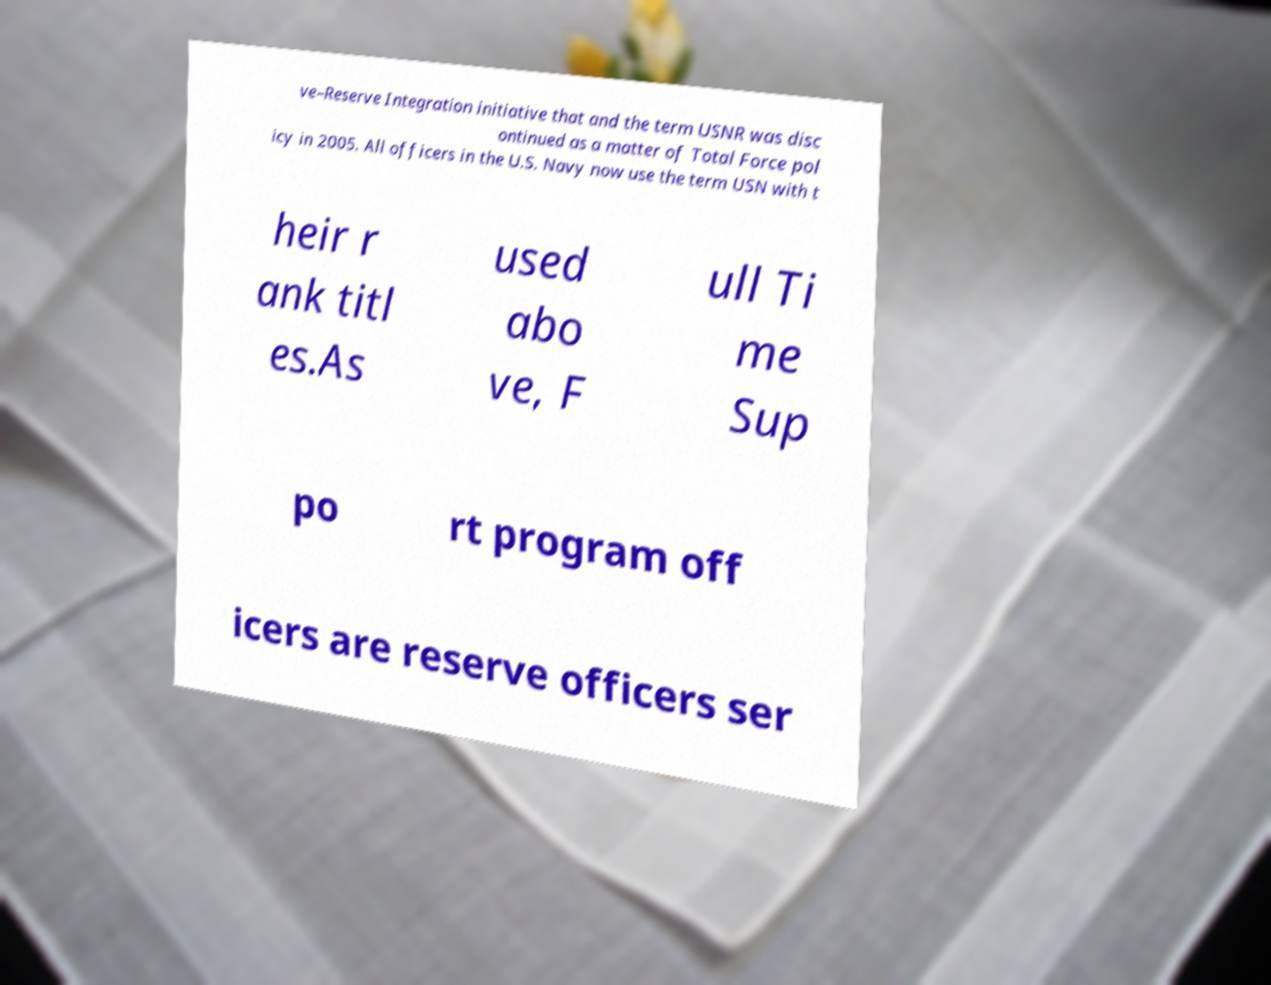For documentation purposes, I need the text within this image transcribed. Could you provide that? ve–Reserve Integration initiative that and the term USNR was disc ontinued as a matter of Total Force pol icy in 2005. All officers in the U.S. Navy now use the term USN with t heir r ank titl es.As used abo ve, F ull Ti me Sup po rt program off icers are reserve officers ser 